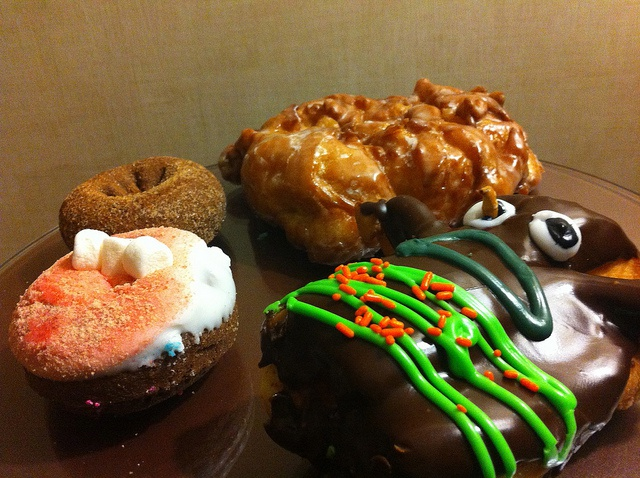Describe the objects in this image and their specific colors. I can see cake in olive, black, maroon, lightgray, and darkgreen tones, donut in olive, tan, ivory, black, and maroon tones, donut in olive, maroon, brown, black, and tan tones, and donut in olive, brown, maroon, and black tones in this image. 